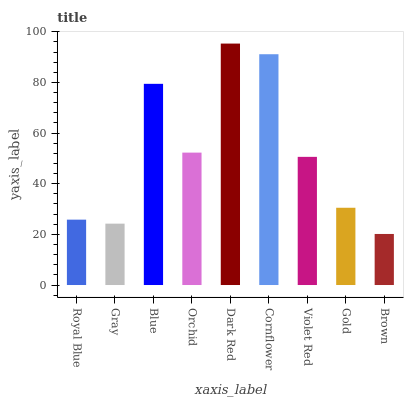Is Brown the minimum?
Answer yes or no. Yes. Is Dark Red the maximum?
Answer yes or no. Yes. Is Gray the minimum?
Answer yes or no. No. Is Gray the maximum?
Answer yes or no. No. Is Royal Blue greater than Gray?
Answer yes or no. Yes. Is Gray less than Royal Blue?
Answer yes or no. Yes. Is Gray greater than Royal Blue?
Answer yes or no. No. Is Royal Blue less than Gray?
Answer yes or no. No. Is Violet Red the high median?
Answer yes or no. Yes. Is Violet Red the low median?
Answer yes or no. Yes. Is Gold the high median?
Answer yes or no. No. Is Royal Blue the low median?
Answer yes or no. No. 